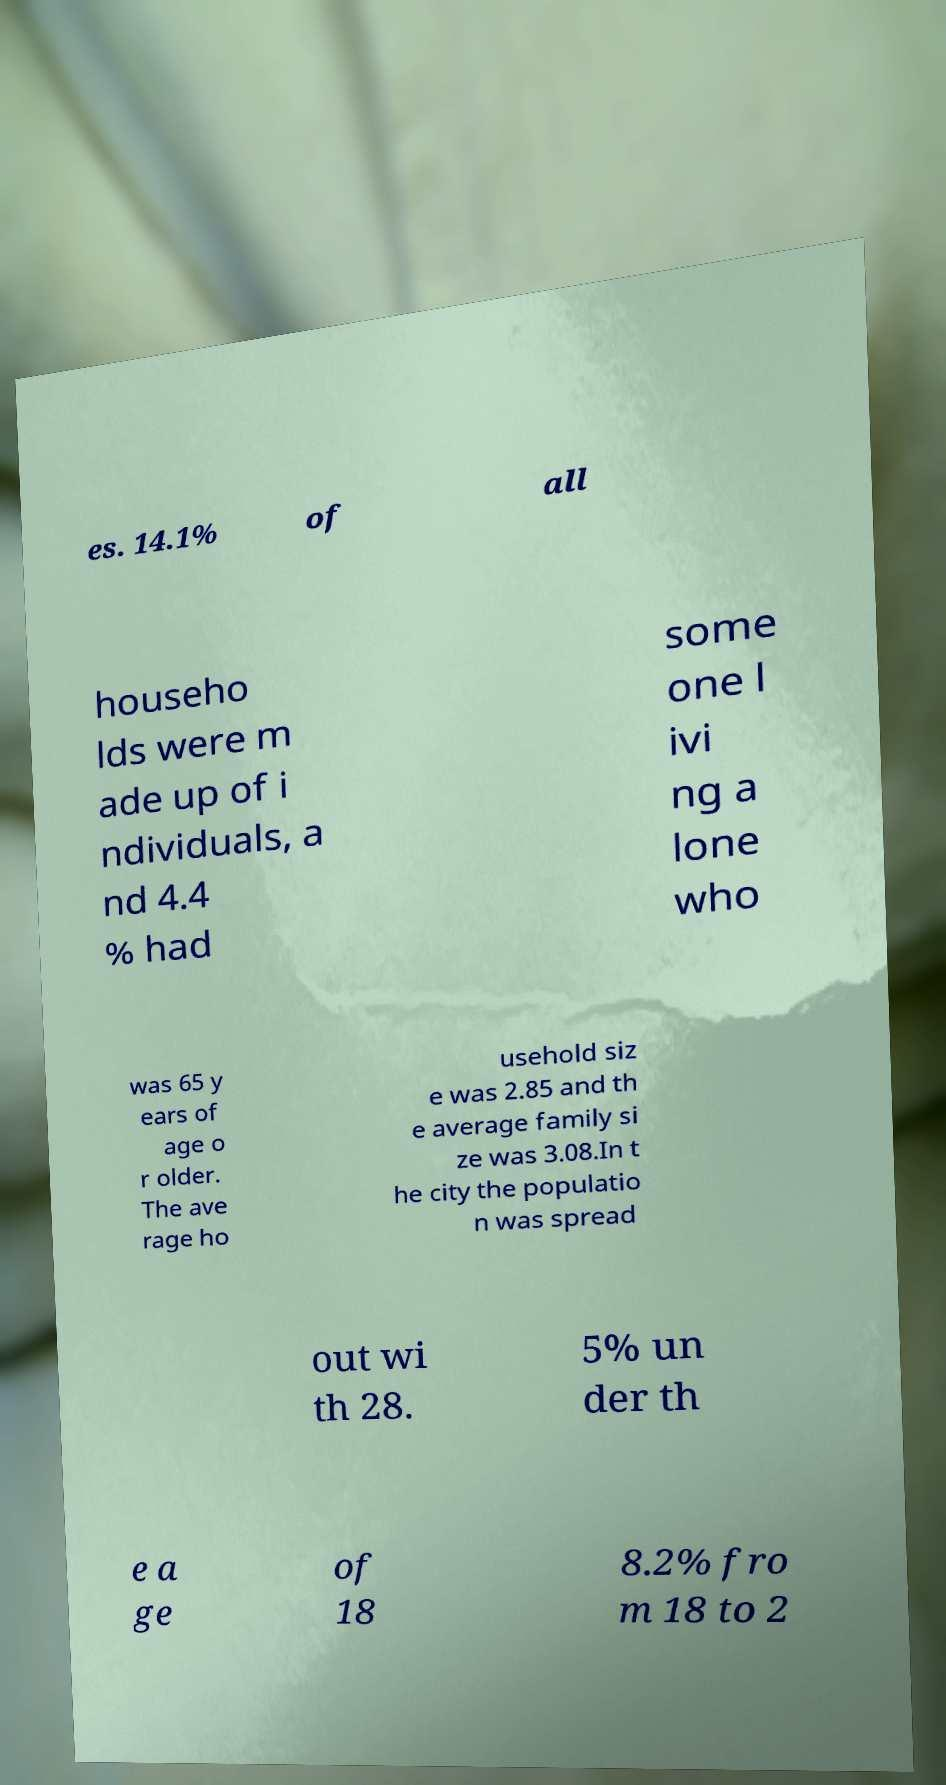Please identify and transcribe the text found in this image. es. 14.1% of all househo lds were m ade up of i ndividuals, a nd 4.4 % had some one l ivi ng a lone who was 65 y ears of age o r older. The ave rage ho usehold siz e was 2.85 and th e average family si ze was 3.08.In t he city the populatio n was spread out wi th 28. 5% un der th e a ge of 18 8.2% fro m 18 to 2 